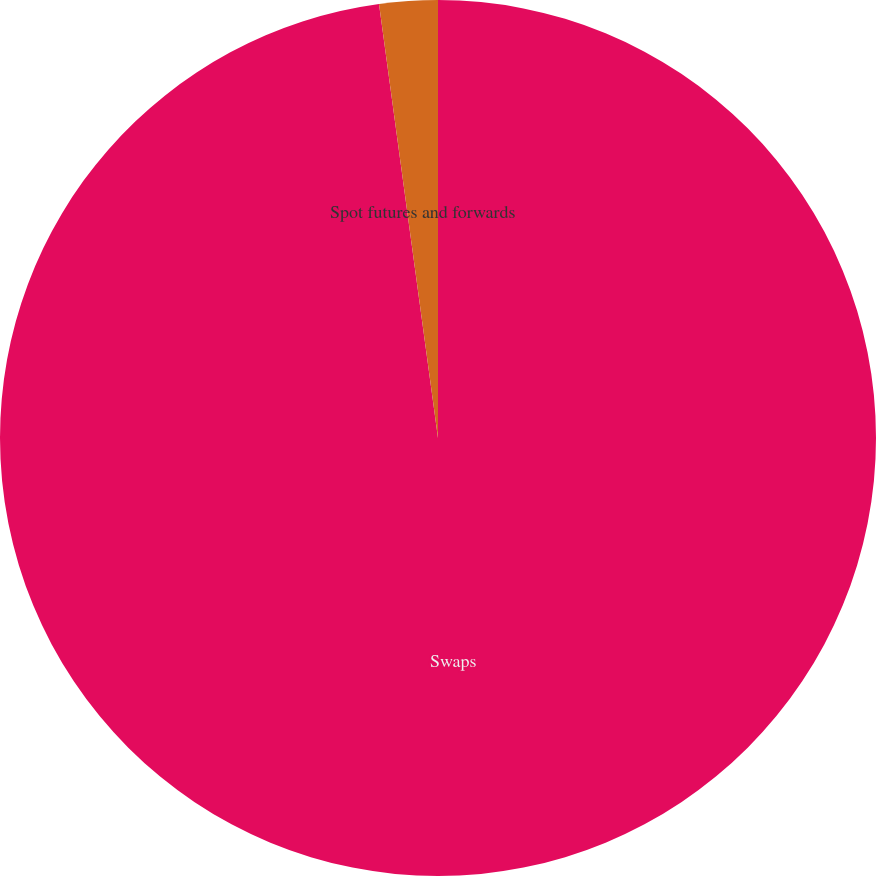<chart> <loc_0><loc_0><loc_500><loc_500><pie_chart><fcel>Swaps<fcel>Spot futures and forwards<nl><fcel>97.85%<fcel>2.15%<nl></chart> 